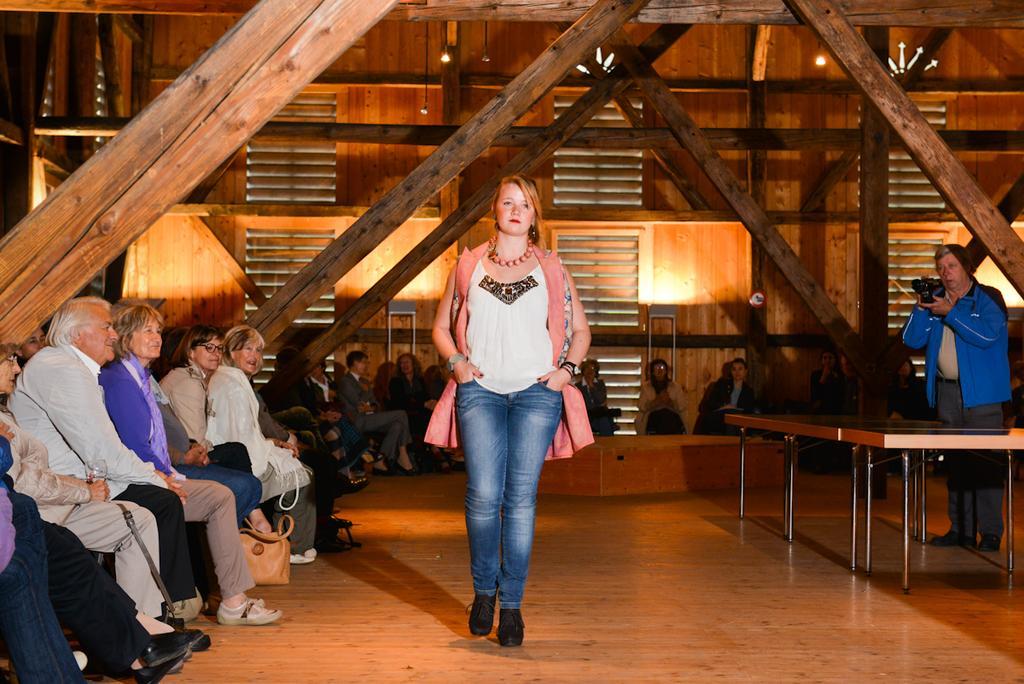Could you give a brief overview of what you see in this image? This is a picture taken in a house, there are the people sitting on the chairs and here is the women in white shirt with blue jeans walking on the wooden floor. Beside the women there is a table and there is a man in blue coat with holding a camera and recording a video of the women and this are wooden pillars. 